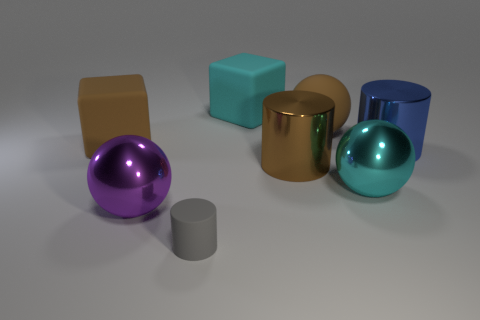There is a rubber cube that is to the right of the brown block; is its color the same as the sphere on the right side of the brown ball?
Your answer should be very brief. Yes. There is a cyan object behind the cyan object that is in front of the large blue object; what is its material?
Your answer should be compact. Rubber. What color is the cylinder that is the same size as the blue thing?
Keep it short and to the point. Brown. There is a tiny gray matte thing; does it have the same shape as the brown thing in front of the large blue object?
Your answer should be very brief. Yes. What shape is the large metal object that is the same color as the rubber sphere?
Offer a very short reply. Cylinder. How many spheres are in front of the brown matte thing to the left of the sphere in front of the cyan metallic ball?
Your response must be concise. 2. How big is the brown rubber object to the right of the big ball on the left side of the rubber cylinder?
Offer a terse response. Large. There is a blue cylinder that is the same material as the purple object; what size is it?
Provide a succinct answer. Large. There is a rubber object that is both in front of the big brown ball and behind the gray matte thing; what is its shape?
Keep it short and to the point. Cube. Are there an equal number of tiny gray cylinders that are behind the small object and large red rubber things?
Your response must be concise. Yes. 